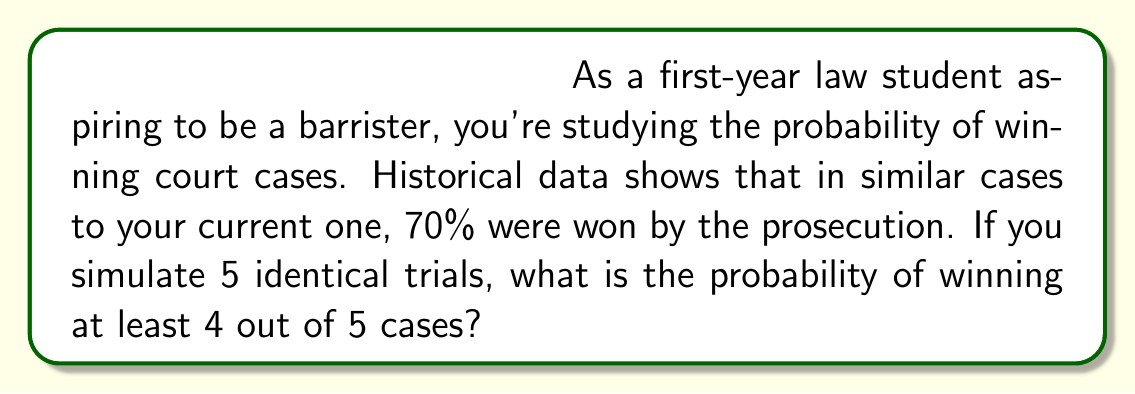Give your solution to this math problem. Let's approach this step-by-step using the binomial probability distribution:

1) We can model this scenario as a binomial distribution where:
   $n = 5$ (number of trials)
   $p = 0.7$ (probability of success in each trial)
   $X$ = number of successes (wins)

2) We need to find $P(X \geq 4)$, which is equivalent to $P(X = 4) + P(X = 5)$

3) The probability mass function for a binomial distribution is:

   $P(X = k) = \binom{n}{k} p^k (1-p)^{n-k}$

4) For $P(X = 4)$:
   $P(X = 4) = \binom{5}{4} (0.7)^4 (0.3)^1$
   $= 5 \cdot (0.7)^4 \cdot (0.3)$
   $= 5 \cdot 0.2401 \cdot 0.3$
   $= 0.36015$

5) For $P(X = 5)$:
   $P(X = 5) = \binom{5}{5} (0.7)^5 (0.3)^0$
   $= 1 \cdot (0.7)^5$
   $= 0.16807$

6) Therefore, $P(X \geq 4) = P(X = 4) + P(X = 5)$
   $= 0.36015 + 0.16807$
   $= 0.52822$
Answer: 0.52822 